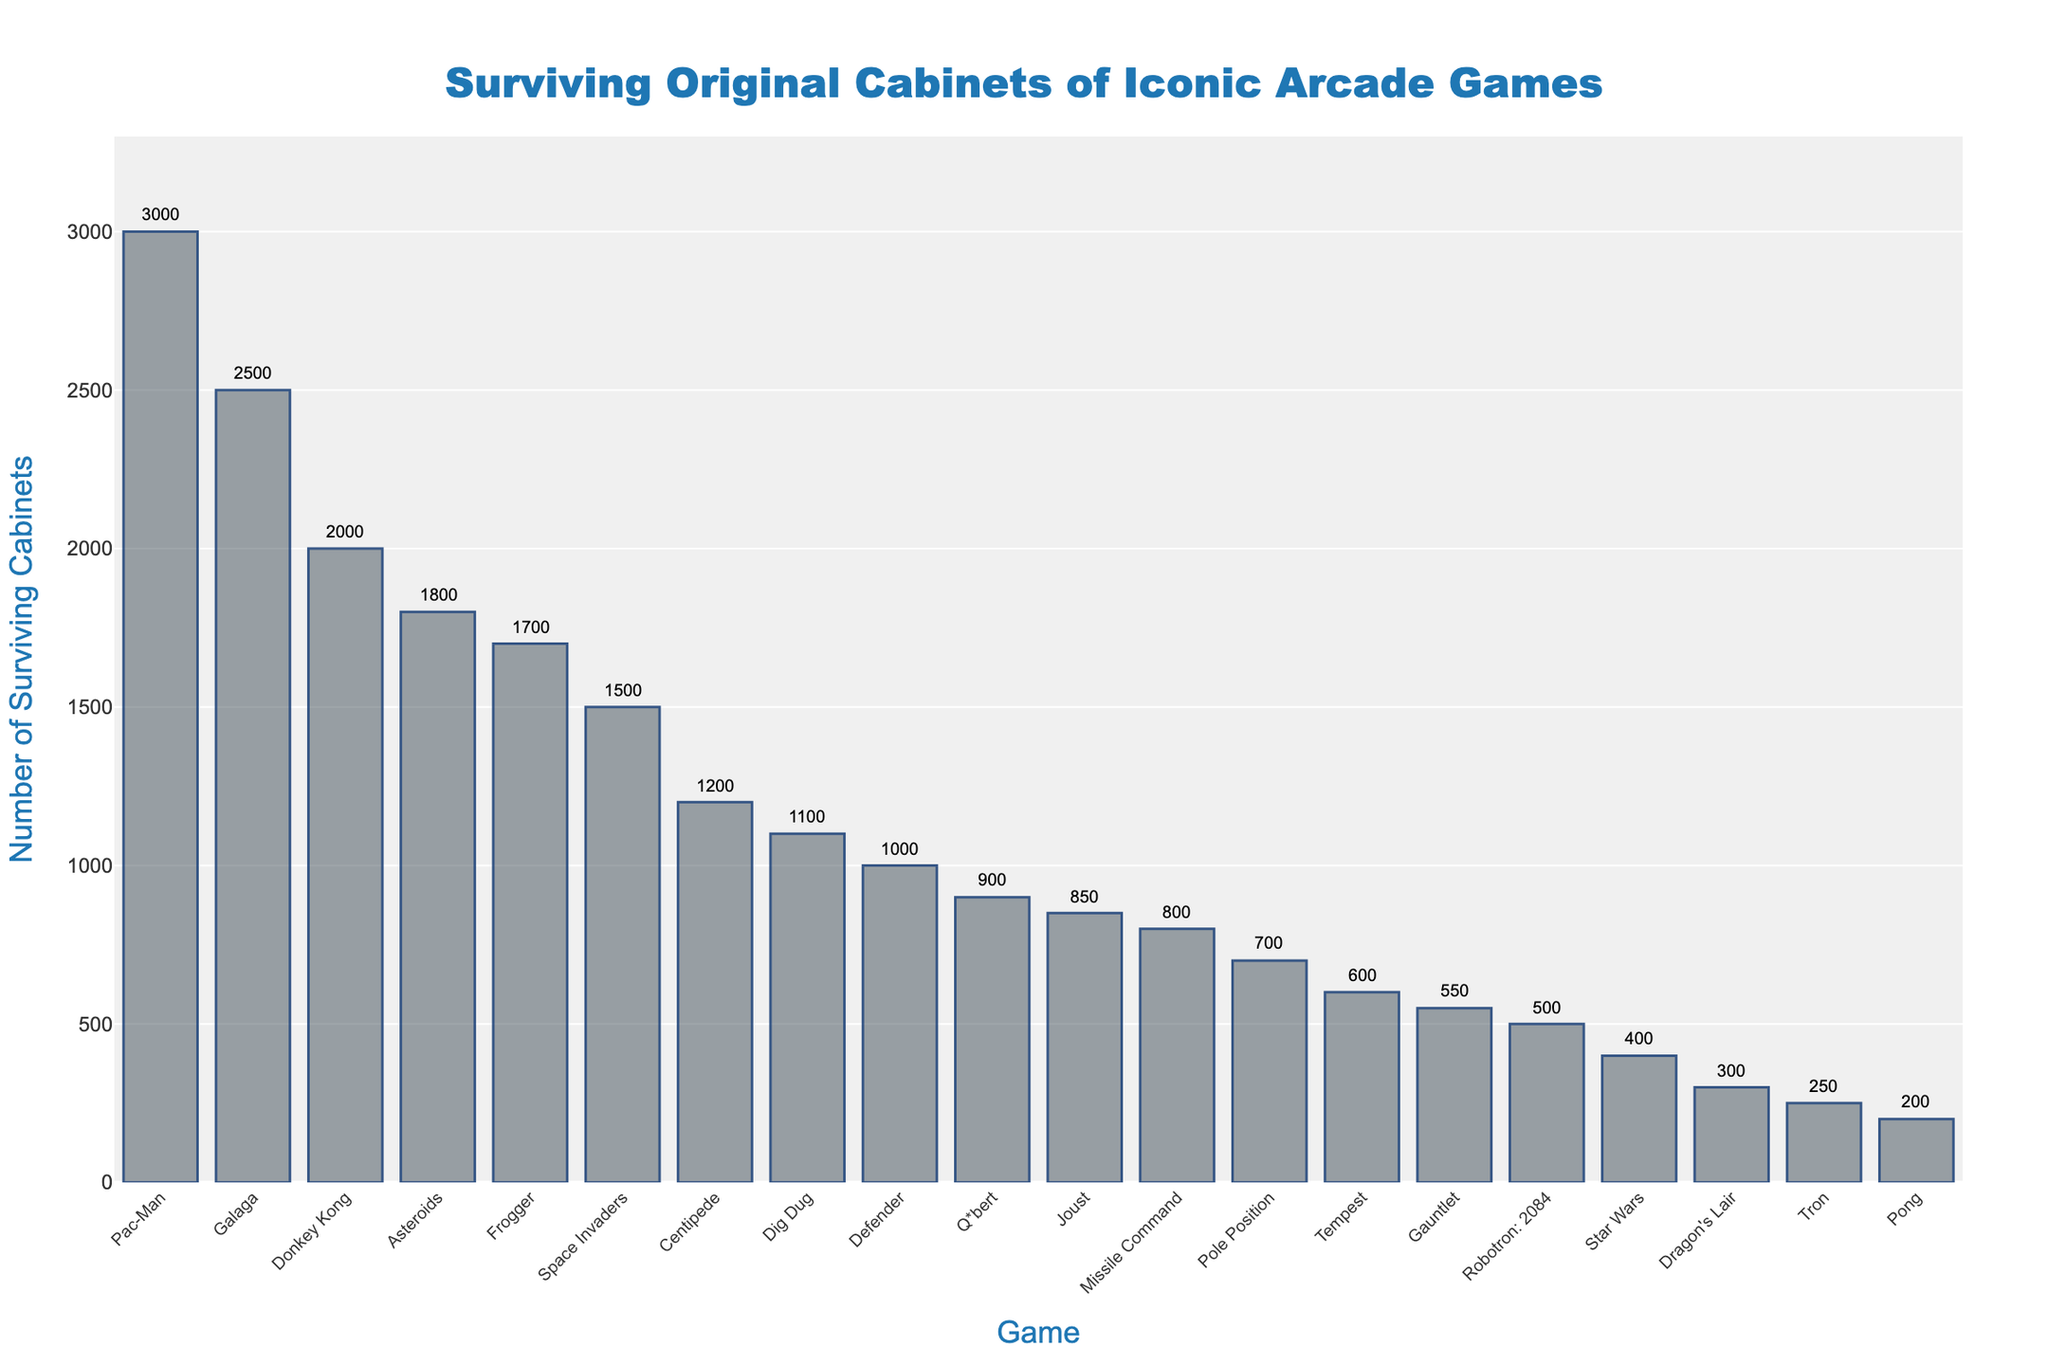What's the name of the game with the highest number of surviving cabinets? The bar chart shows that "Pac-Man" has the tallest bar, representing the highest number of surviving cabinets at 3000.
Answer: Pac-Man Which game has more surviving cabinets: "Donkey Kong" or "Frogger"? From the bar chart, "Donkey Kong" has taller bar than "Frogger". "Donkey Kong" has 2000 while "Frogger" has 1700 surviving cabinets.
Answer: Donkey Kong What is the total number of surviving cabinets for "Asteroids" and "Galaga"? To find the total, add the number of surviving cabinets for both games: Asteroids (1800) + Galaga (2500) = 4300.
Answer: 4300 What is the difference in the number of surviving cabinets between "Defender" and "Pole Position"? Calculate the difference: Defender (1000) - Pole Position (700) = 300.
Answer: 300 Which game has the fewest surviving cabinets? The bar chart shows that "Tron" has the shortest bar, representing 250 surviving cabinets.
Answer: Tron What is the average number of surviving cabinets across all the games? First, sum the number of surviving cabinets for all games: 200 + 1500 + 3000 + 2000 + 1800 + 2500 + 1200 + 1000 + 800 + 1700 + 600 + 900 + 400 + 300 + 700 + 1100 + 500 + 850 + 250 + 550 = 22550. Then, divide by the number of games (20): 22550 / 20 = 1127.5.
Answer: 1127.5 How many more "Centipede" cabinets are there compared to "Star Wars" cabinets? Calculate the difference: Centipede (1200) - Star Wars (400) = 800.
Answer: 800 How does the number of "Q*bert" cabinets compare to "Missile Command" cabinets? From the bar chart, "Q*bert" has 900 surviving cabinets while "Missile Command" has 800. "Q*bert" has 100 more surviving cabinets.
Answer: Q*bert has more What's the combined number of surviving cabinets for games with fewer than 1000 surviving units? Identify the games with fewer than 1000 surviving cabinets: Pong (200), Tempest (600), Star Wars (400), Dragon's Lair (300), Pole Position (700), Robotron: 2084 (500), Tron (250), Gauntlet (550). Add these numbers: 200 + 600 + 400 + 300 + 700 + 500 + 250 + 550 = 3500.
Answer: 3500 